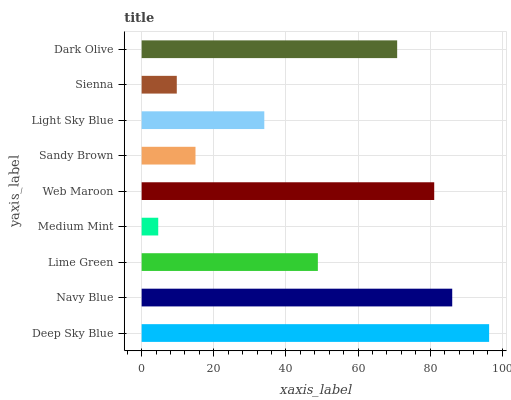Is Medium Mint the minimum?
Answer yes or no. Yes. Is Deep Sky Blue the maximum?
Answer yes or no. Yes. Is Navy Blue the minimum?
Answer yes or no. No. Is Navy Blue the maximum?
Answer yes or no. No. Is Deep Sky Blue greater than Navy Blue?
Answer yes or no. Yes. Is Navy Blue less than Deep Sky Blue?
Answer yes or no. Yes. Is Navy Blue greater than Deep Sky Blue?
Answer yes or no. No. Is Deep Sky Blue less than Navy Blue?
Answer yes or no. No. Is Lime Green the high median?
Answer yes or no. Yes. Is Lime Green the low median?
Answer yes or no. Yes. Is Sandy Brown the high median?
Answer yes or no. No. Is Navy Blue the low median?
Answer yes or no. No. 